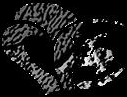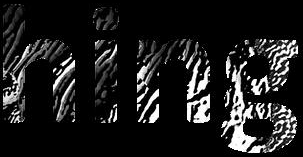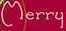Read the text from these images in sequence, separated by a semicolon. #; hing; Merry 